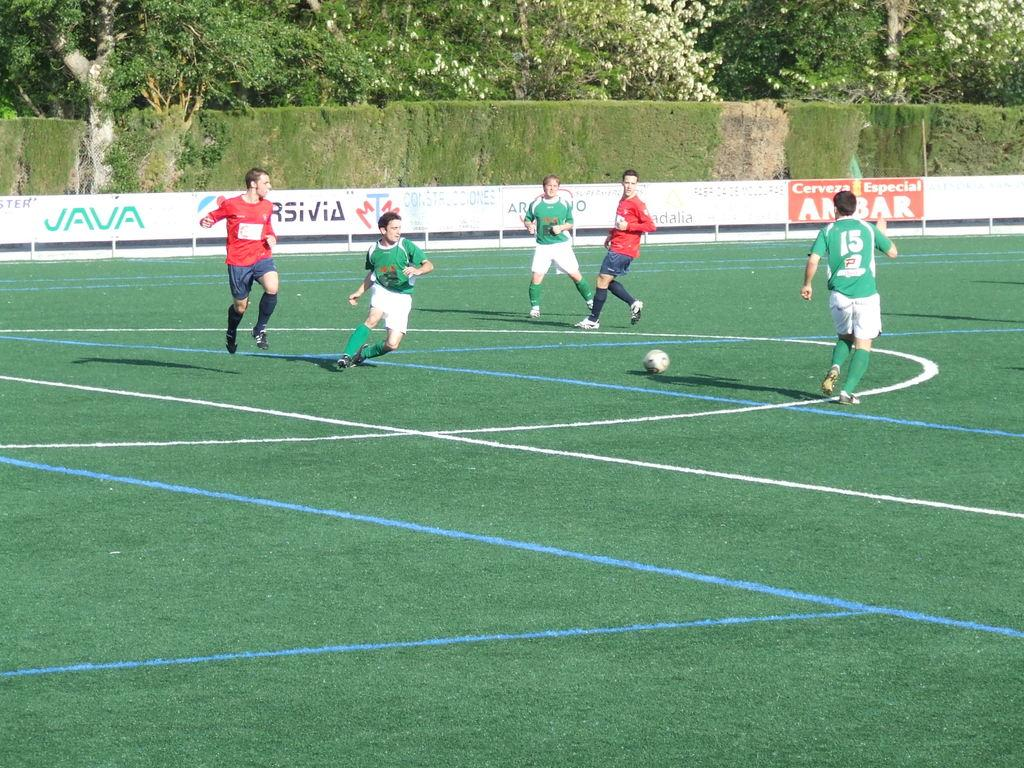<image>
Render a clear and concise summary of the photo. guys wearing red and green jerseys playing soccer and fence signs with words such as vava and cervera especial ambar in the background 